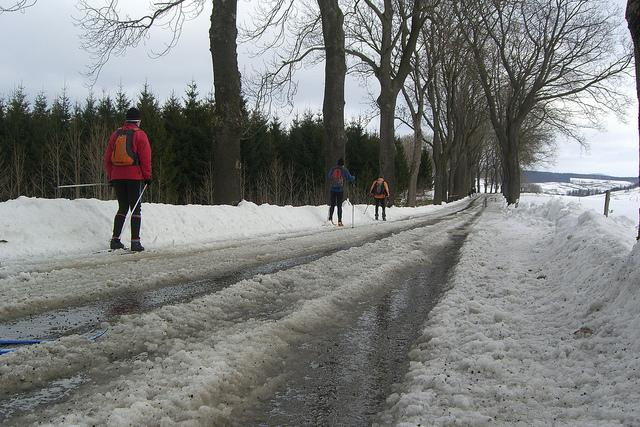What caused the deepest mushiest tracks here? Please explain your reasoning. automobiles. Cars caused the gray tracks. 